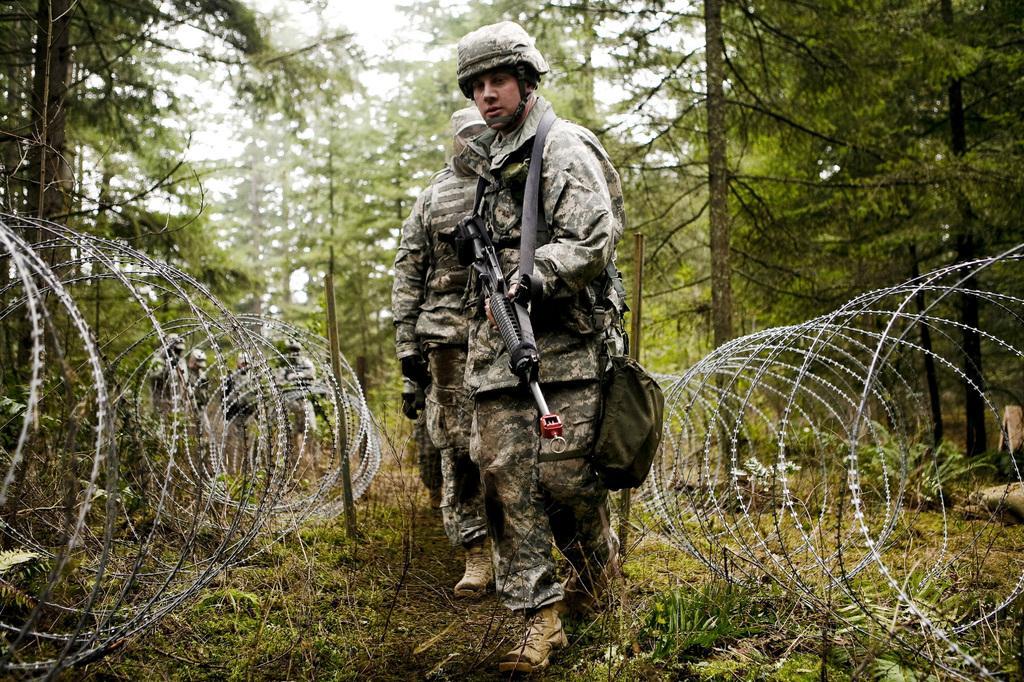Could you give a brief overview of what you see in this image? This image consists of few persons wearing the army dresses and holding guns. On the left and right, we can see a metal fencing. In the background, there are trees. At the bottom, there is ground. 